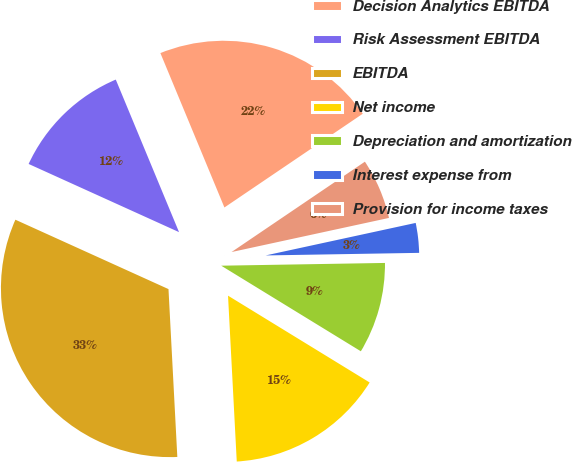Convert chart. <chart><loc_0><loc_0><loc_500><loc_500><pie_chart><fcel>Decision Analytics EBITDA<fcel>Risk Assessment EBITDA<fcel>EBITDA<fcel>Net income<fcel>Depreciation and amortization<fcel>Interest expense from<fcel>Provision for income taxes<nl><fcel>21.78%<fcel>11.97%<fcel>32.61%<fcel>15.41%<fcel>9.02%<fcel>3.13%<fcel>6.08%<nl></chart> 